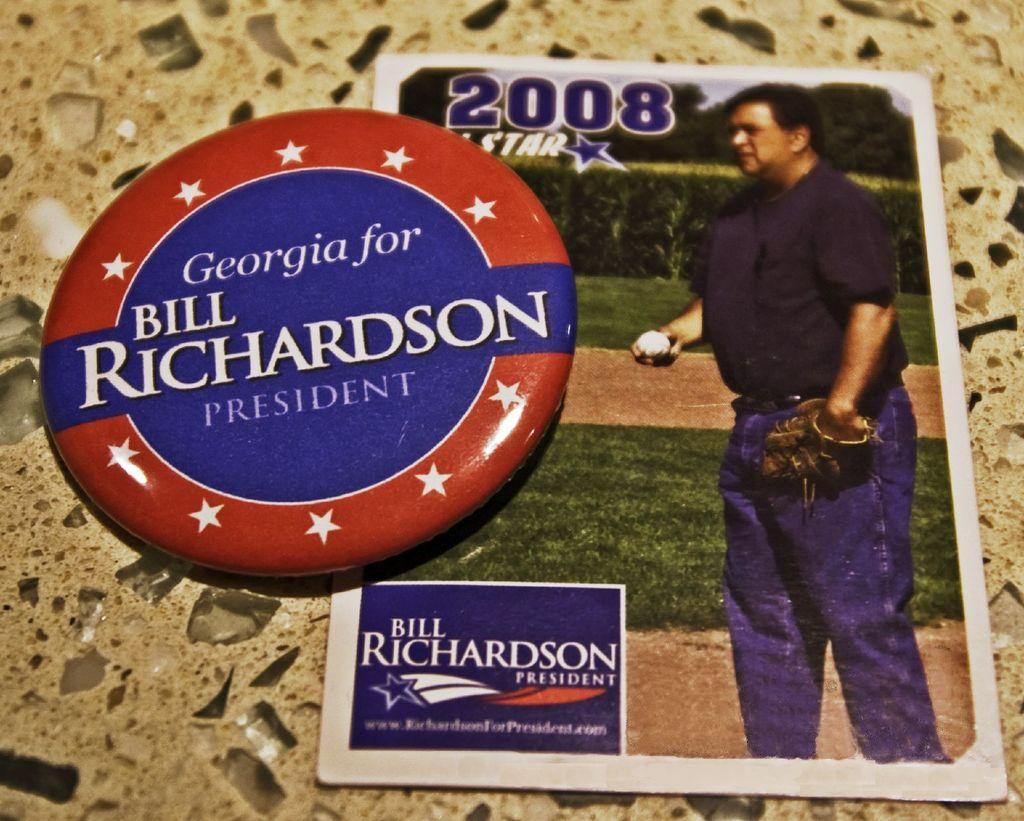How would you summarize this image in a sentence or two? In the center of the image there is a badge. There is a card on the floor. 